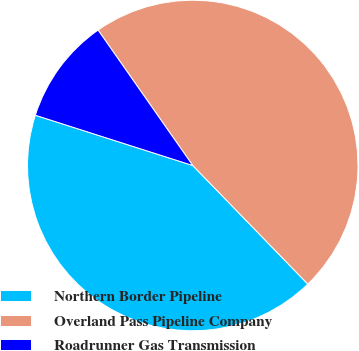Convert chart to OTSL. <chart><loc_0><loc_0><loc_500><loc_500><pie_chart><fcel>Northern Border Pipeline<fcel>Overland Pass Pipeline Company<fcel>Roadrunner Gas Transmission<nl><fcel>42.18%<fcel>47.45%<fcel>10.37%<nl></chart> 